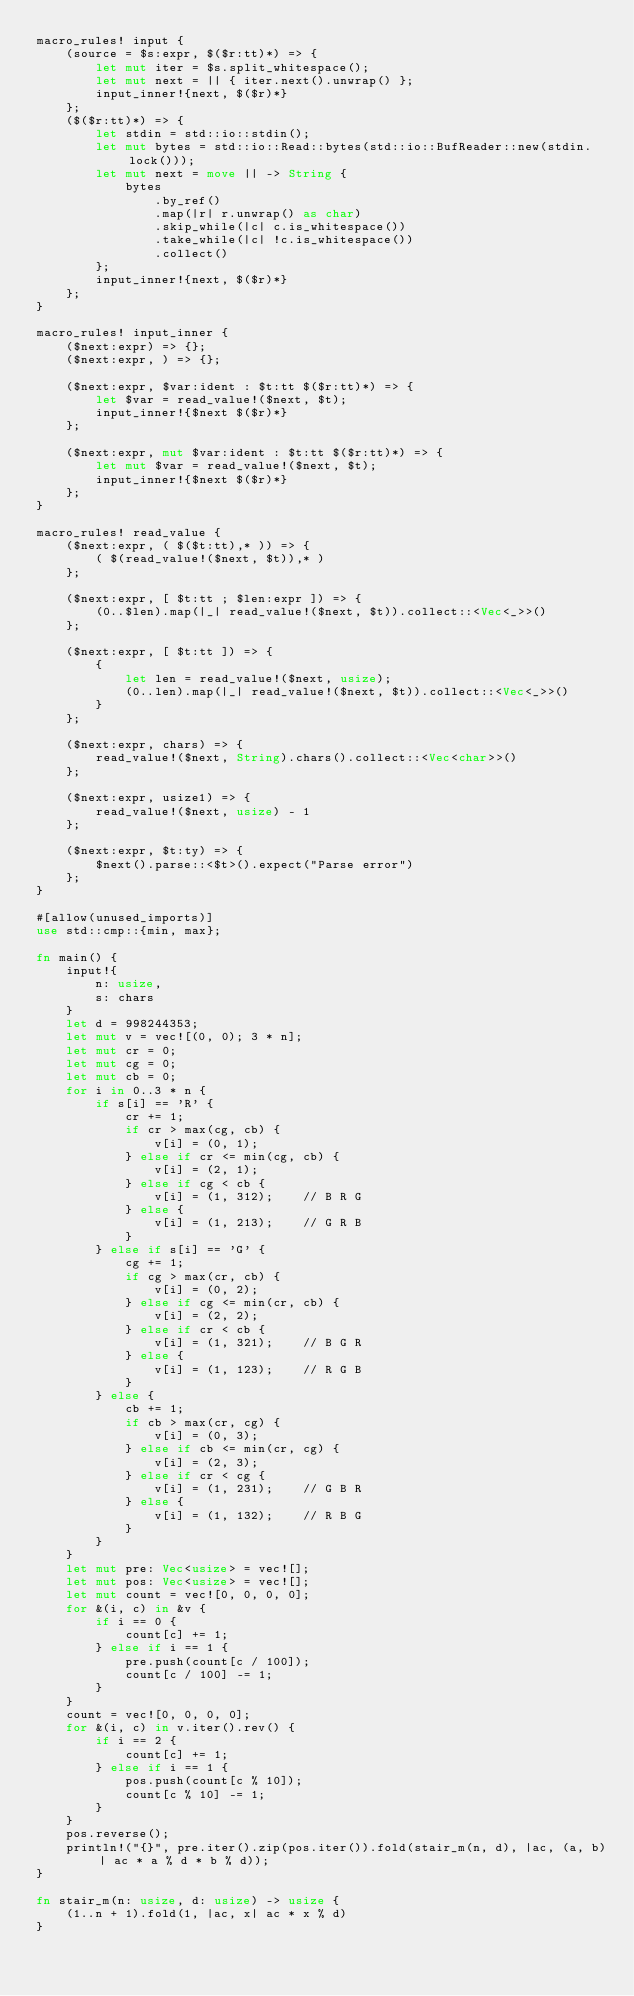<code> <loc_0><loc_0><loc_500><loc_500><_Rust_>macro_rules! input {
    (source = $s:expr, $($r:tt)*) => {
        let mut iter = $s.split_whitespace();
        let mut next = || { iter.next().unwrap() };
        input_inner!{next, $($r)*}
    };
    ($($r:tt)*) => {
        let stdin = std::io::stdin();
        let mut bytes = std::io::Read::bytes(std::io::BufReader::new(stdin.lock()));
        let mut next = move || -> String {
            bytes
                .by_ref()
                .map(|r| r.unwrap() as char)
                .skip_while(|c| c.is_whitespace())
                .take_while(|c| !c.is_whitespace())
                .collect()
        };
        input_inner!{next, $($r)*}
    };
}

macro_rules! input_inner {
    ($next:expr) => {};
    ($next:expr, ) => {};

    ($next:expr, $var:ident : $t:tt $($r:tt)*) => {
        let $var = read_value!($next, $t);
        input_inner!{$next $($r)*}
    };

    ($next:expr, mut $var:ident : $t:tt $($r:tt)*) => {
        let mut $var = read_value!($next, $t);
        input_inner!{$next $($r)*}
    };
}

macro_rules! read_value {
    ($next:expr, ( $($t:tt),* )) => {
        ( $(read_value!($next, $t)),* )
    };

    ($next:expr, [ $t:tt ; $len:expr ]) => {
        (0..$len).map(|_| read_value!($next, $t)).collect::<Vec<_>>()
    };

    ($next:expr, [ $t:tt ]) => {
        {
            let len = read_value!($next, usize);
            (0..len).map(|_| read_value!($next, $t)).collect::<Vec<_>>()
        }
    };

    ($next:expr, chars) => {
        read_value!($next, String).chars().collect::<Vec<char>>()
    };

    ($next:expr, usize1) => {
        read_value!($next, usize) - 1
    };

    ($next:expr, $t:ty) => {
        $next().parse::<$t>().expect("Parse error")
    };
}

#[allow(unused_imports)]
use std::cmp::{min, max};

fn main() {
    input!{
        n: usize,
        s: chars
    }
    let d = 998244353;
    let mut v = vec![(0, 0); 3 * n];
    let mut cr = 0;
    let mut cg = 0;
    let mut cb = 0;
    for i in 0..3 * n {
        if s[i] == 'R' {
            cr += 1;
            if cr > max(cg, cb) {
                v[i] = (0, 1);
            } else if cr <= min(cg, cb) {
                v[i] = (2, 1);
            } else if cg < cb {
                v[i] = (1, 312);    // B R G
            } else {
                v[i] = (1, 213);    // G R B
            }
        } else if s[i] == 'G' {
            cg += 1;
            if cg > max(cr, cb) {
                v[i] = (0, 2);
            } else if cg <= min(cr, cb) {
                v[i] = (2, 2);
            } else if cr < cb {
                v[i] = (1, 321);    // B G R
            } else {
                v[i] = (1, 123);    // R G B
            }
        } else {
            cb += 1;
            if cb > max(cr, cg) {
                v[i] = (0, 3);
            } else if cb <= min(cr, cg) {
                v[i] = (2, 3);
            } else if cr < cg {
                v[i] = (1, 231);    // G B R
            } else {
                v[i] = (1, 132);    // R B G
            }
        }
    }
    let mut pre: Vec<usize> = vec![];
    let mut pos: Vec<usize> = vec![];
    let mut count = vec![0, 0, 0, 0];
    for &(i, c) in &v {
        if i == 0 {
            count[c] += 1;
        } else if i == 1 {
            pre.push(count[c / 100]);
            count[c / 100] -= 1;
        }
    }
    count = vec![0, 0, 0, 0];
    for &(i, c) in v.iter().rev() {
        if i == 2 {
            count[c] += 1;
        } else if i == 1 {
            pos.push(count[c % 10]);
            count[c % 10] -= 1;
        }
    }
    pos.reverse();
    println!("{}", pre.iter().zip(pos.iter()).fold(stair_m(n, d), |ac, (a, b)| ac * a % d * b % d));
}

fn stair_m(n: usize, d: usize) -> usize {
    (1..n + 1).fold(1, |ac, x| ac * x % d)
}
</code> 